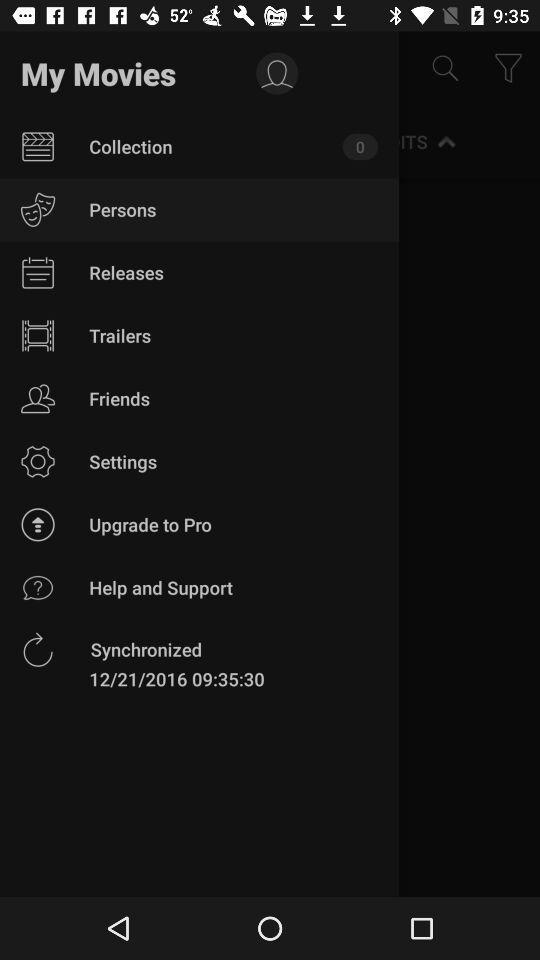Which item has been selected? The selected item is "Persons". 